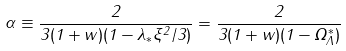Convert formula to latex. <formula><loc_0><loc_0><loc_500><loc_500>\alpha \equiv \frac { 2 } { 3 ( 1 + w ) ( 1 - \lambda _ { \ast } \xi ^ { 2 } / 3 ) } = \frac { 2 } { 3 ( 1 + w ) ( 1 - \Omega ^ { \ast } _ { \Lambda } ) }</formula> 